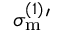<formula> <loc_0><loc_0><loc_500><loc_500>\sigma _ { m } ^ { ( 1 ) ^ { \prime }</formula> 